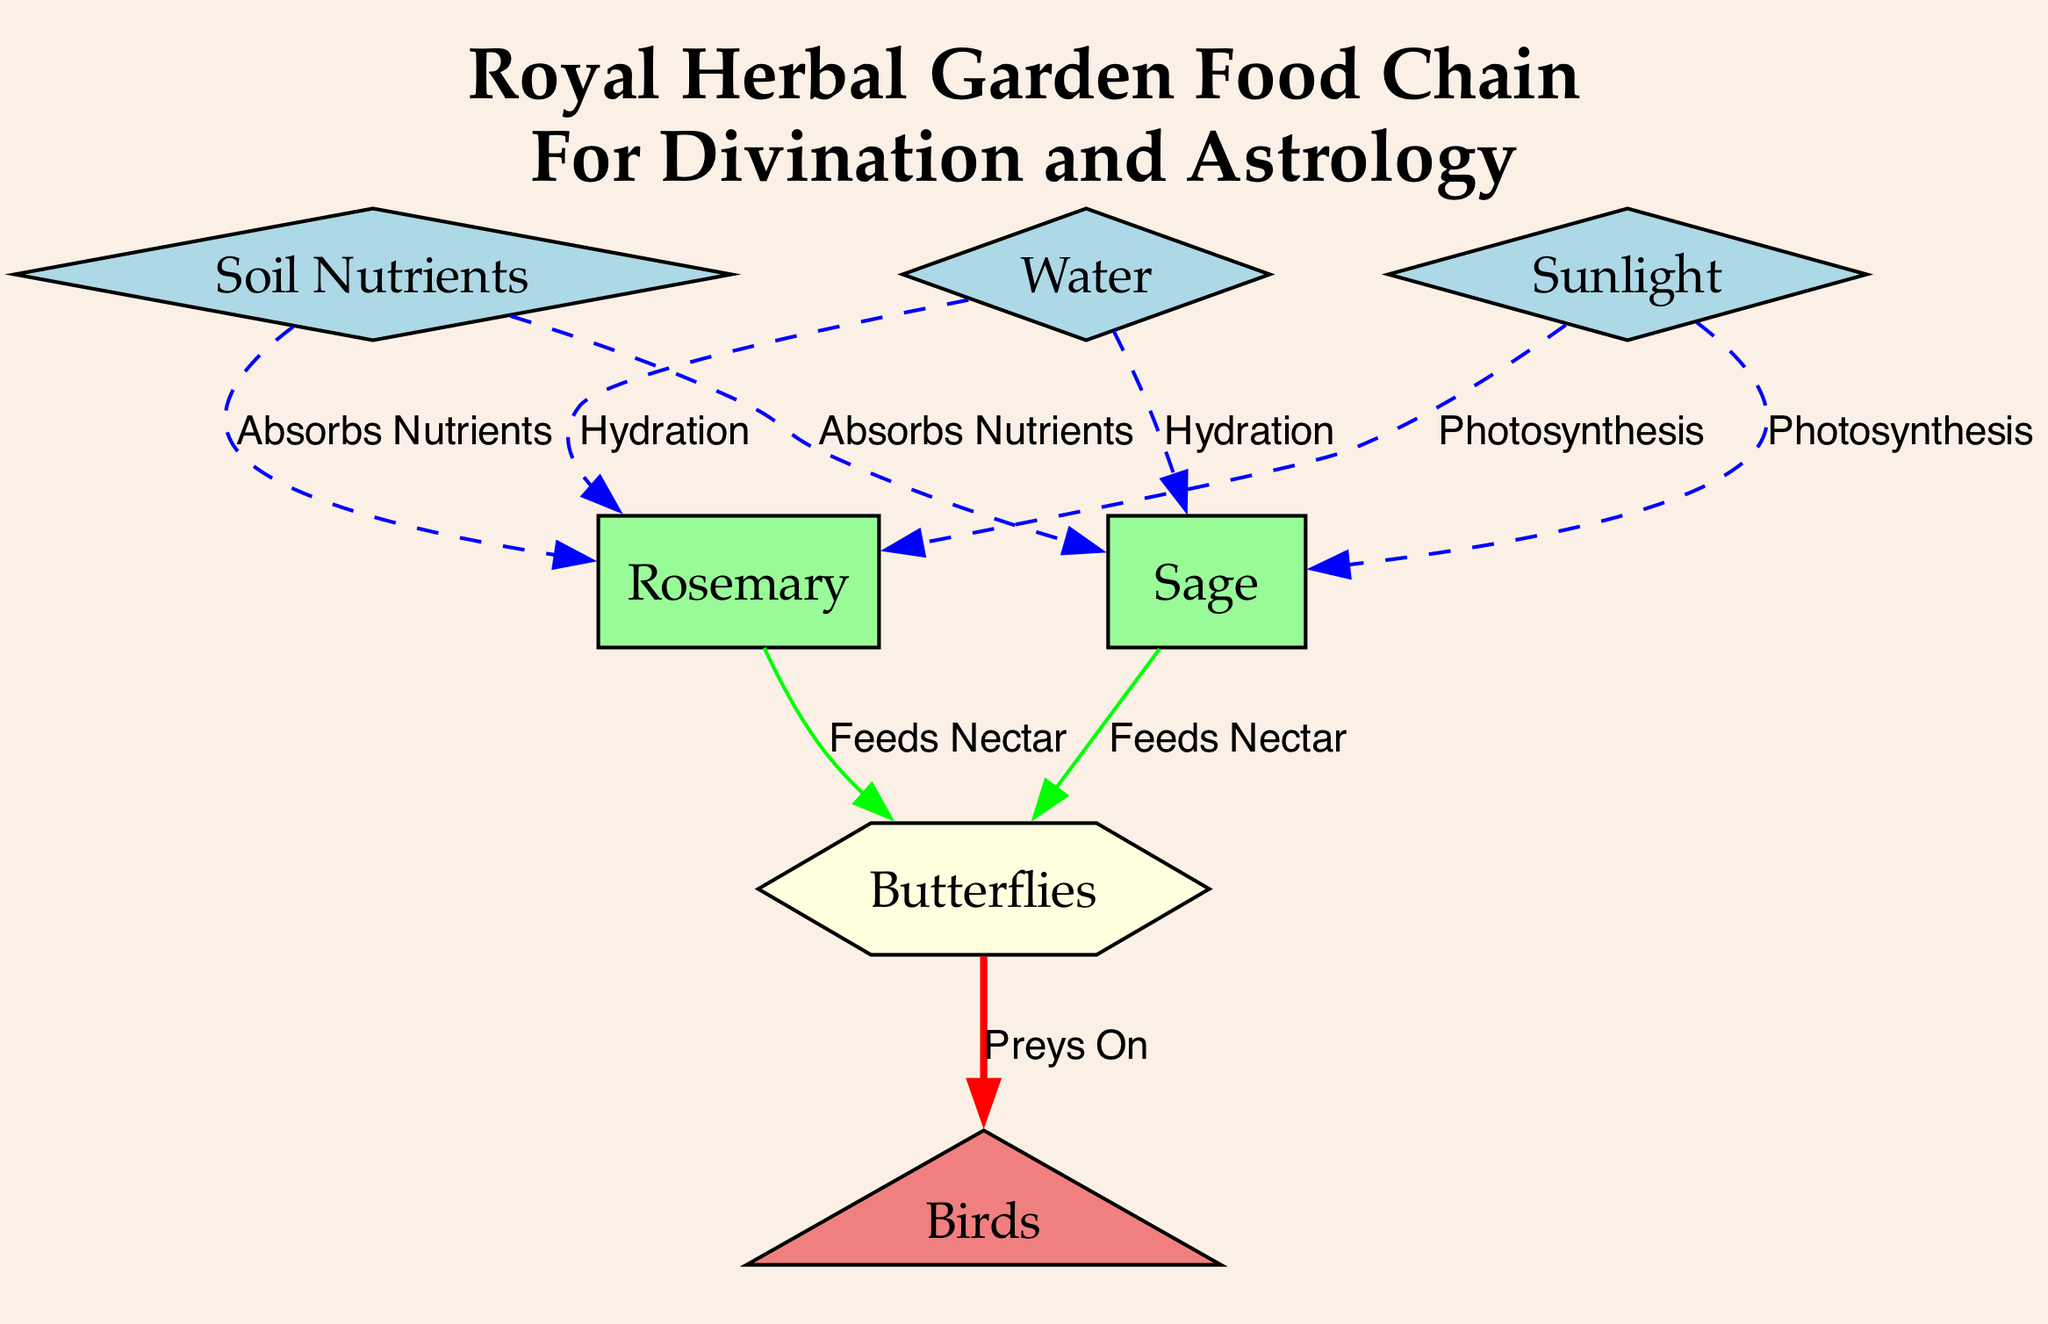What are the primary soil nutrients in the garden? The diagram indicates "Soil Nutrients", specifically macronutrients like nitrogen and phosphorus.
Answer: Soil Nutrients How many plants are featured in the diagram? There are two plants shown in the diagram representing the herbal garden: sage and rosemary.
Answer: 2 What does sage provide to butterflies? The diagram states that sage "Feeds Nectar" to butterflies, indicating it serves as food for them.
Answer: Feeds Nectar Which nutrient is essential for photosynthesis in the garden? Sunlight is indicated in the diagram as the energy source required for photosynthesis essential for both sage and rosemary plants.
Answer: Sunlight What do birds primarily feed on in the herbal garden? The diagram illustrates that birds "Preys On" butterflies, showing the predator-prey relationship.
Answer: Butterflies How are butterflies classified in the diagram? The diagram identifies butterflies as hexagon-shaped nodes, reflecting their role as pollinators and their relation to the plants in the garden.
Answer: Hexagon What role does water play in the garden for sage and rosemary? The diagram specifies that water provides "Hydration" to both sage and rosemary, indicating its vital role for these plants.
Answer: Hydration What color represents the soil nutrients in the diagram? The nodes for soil nutrients are depicted in light blue, distinguishing them from other elements in the diagram.
Answer: Light Blue Which plant is associated with enhancing memory? Rosemary is explicitly labeled in the diagram as the plant known for enhancing memory and prediction in divination.
Answer: Rosemary 